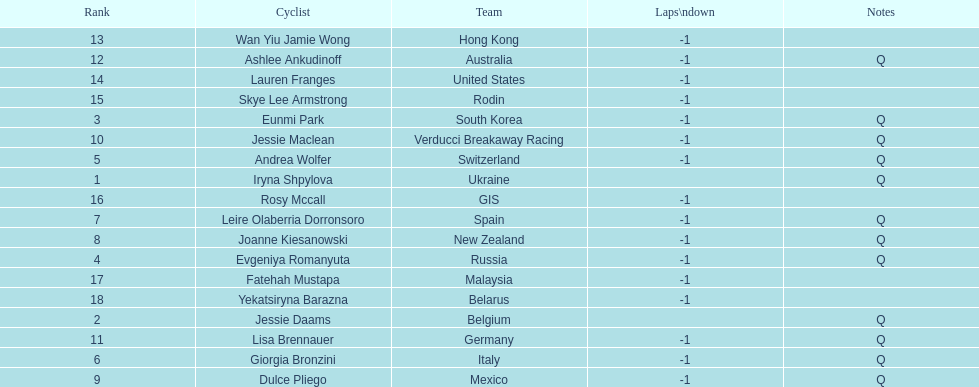How many cyclist do not have -1 laps down? 2. 